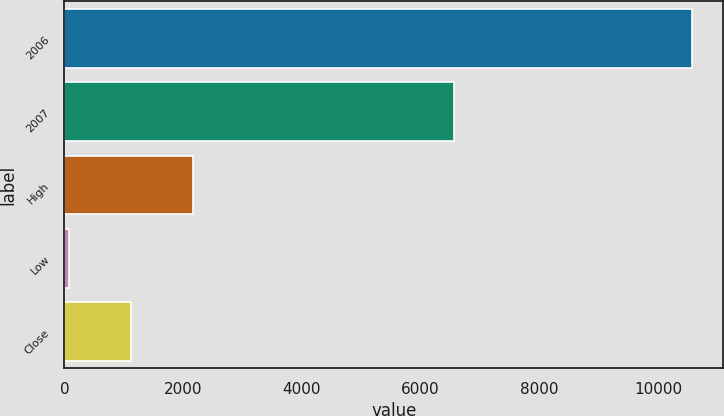<chart> <loc_0><loc_0><loc_500><loc_500><bar_chart><fcel>2006<fcel>2007<fcel>High<fcel>Low<fcel>Close<nl><fcel>10570<fcel>6562<fcel>2168.42<fcel>68.02<fcel>1118.22<nl></chart> 